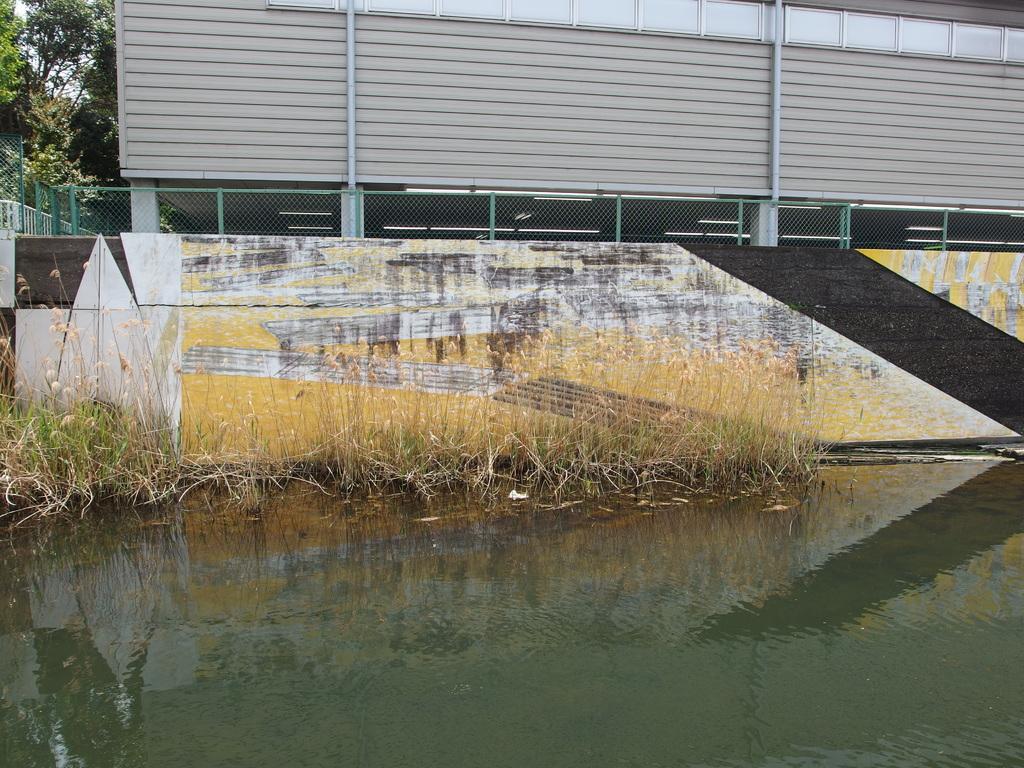Please provide a concise description of this image. This image consists of water. In the front, there are plants, beside the wall. There is a fencing on the wall. In the front, there is a building. To the left, there are trees. 